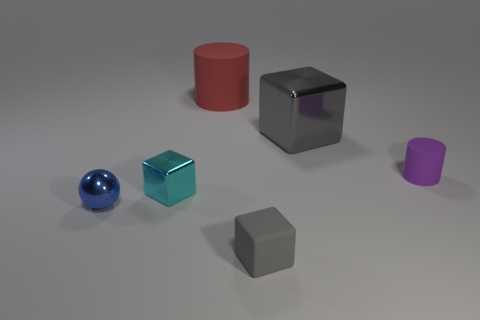Subtract all metallic blocks. How many blocks are left? 1 Subtract all red cylinders. How many gray cubes are left? 2 Add 2 rubber cylinders. How many objects exist? 8 Subtract 1 blocks. How many blocks are left? 2 Add 4 tiny purple cylinders. How many tiny purple cylinders exist? 5 Subtract 0 yellow cylinders. How many objects are left? 6 Subtract all cylinders. How many objects are left? 4 Subtract all yellow cubes. Subtract all green cylinders. How many cubes are left? 3 Subtract all small purple matte balls. Subtract all blue balls. How many objects are left? 5 Add 5 small gray rubber cubes. How many small gray rubber cubes are left? 6 